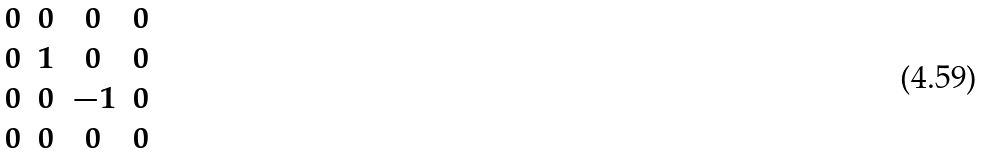<formula> <loc_0><loc_0><loc_500><loc_500>\begin{matrix} 0 & 0 & 0 & 0 \\ 0 & 1 & 0 & 0 \\ 0 & 0 & - 1 & 0 \\ 0 & 0 & 0 & 0 \end{matrix}</formula> 